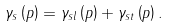<formula> <loc_0><loc_0><loc_500><loc_500>\gamma _ { s } \left ( p \right ) = \gamma _ { s l } \left ( p \right ) + \gamma _ { s t } \left ( p \right ) .</formula> 